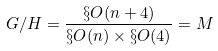Convert formula to latex. <formula><loc_0><loc_0><loc_500><loc_500>G / H = \frac { \S O ( n + 4 ) } { \S O ( n ) \times \S O ( 4 ) } = M</formula> 